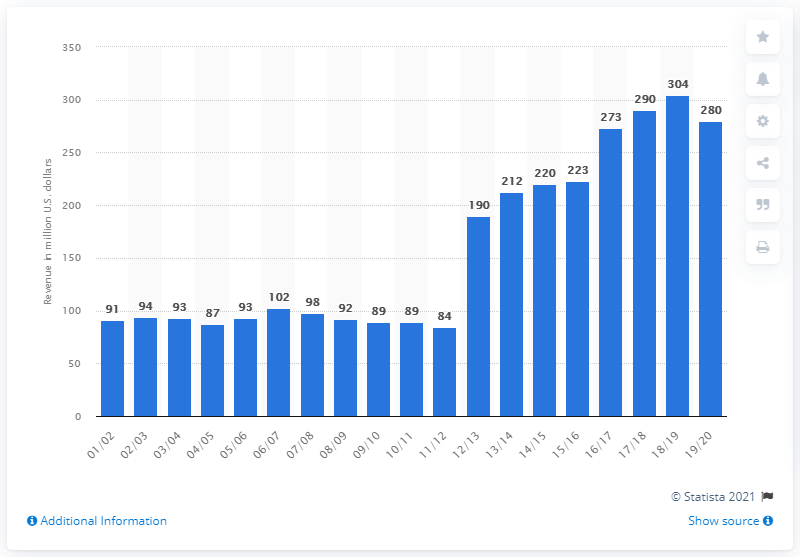Highlight a few significant elements in this photo. According to estimates, the estimated revenue of a National Basketball Association franchise in 2019/2020 was approximately 280 million U.S. dollars. 